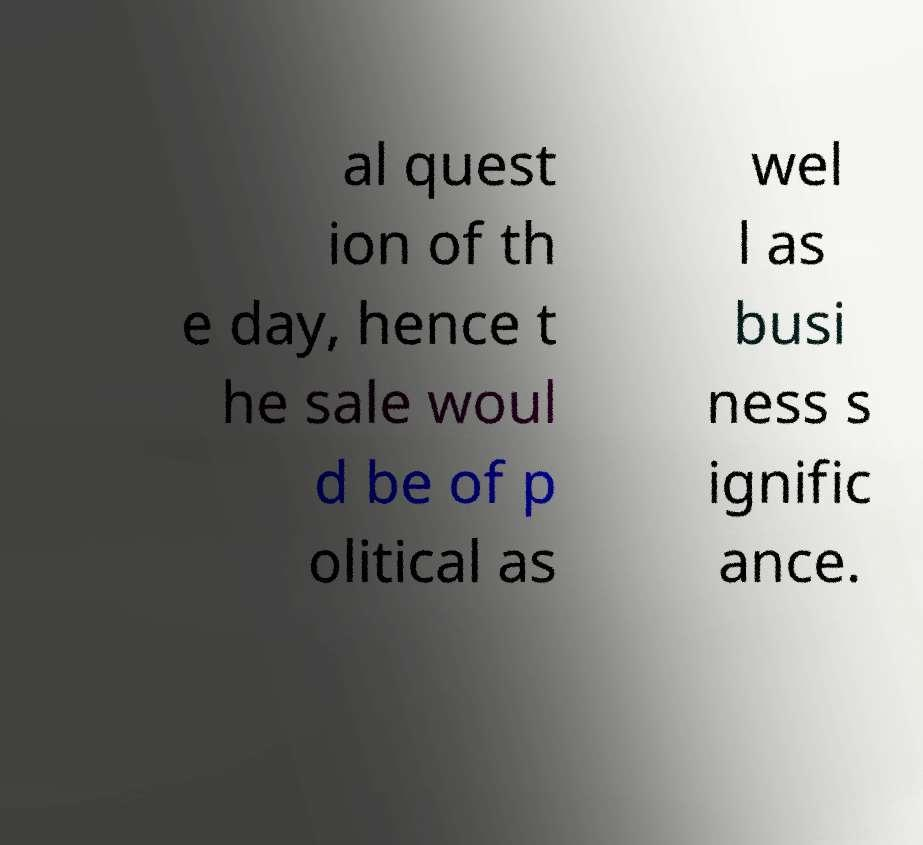Could you extract and type out the text from this image? al quest ion of th e day, hence t he sale woul d be of p olitical as wel l as busi ness s ignific ance. 